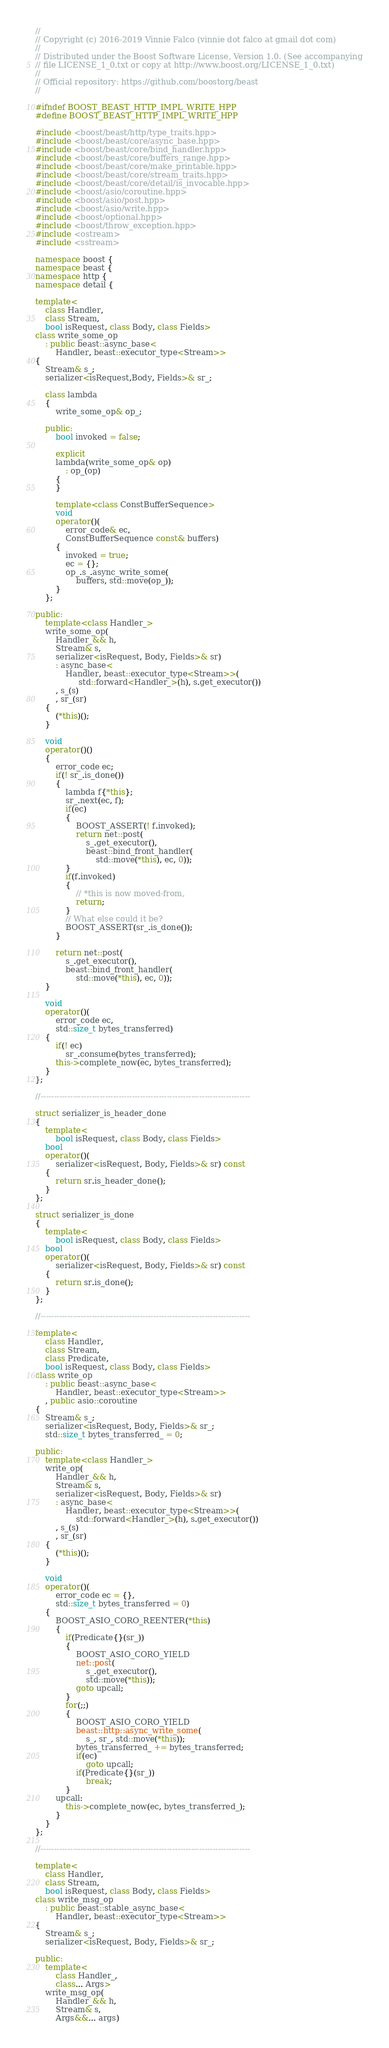Convert code to text. <code><loc_0><loc_0><loc_500><loc_500><_C++_>//
// Copyright (c) 2016-2019 Vinnie Falco (vinnie dot falco at gmail dot com)
//
// Distributed under the Boost Software License, Version 1.0. (See accompanying
// file LICENSE_1_0.txt or copy at http://www.boost.org/LICENSE_1_0.txt)
//
// Official repository: https://github.com/boostorg/beast
//

#ifndef BOOST_BEAST_HTTP_IMPL_WRITE_HPP
#define BOOST_BEAST_HTTP_IMPL_WRITE_HPP

#include <boost/beast/http/type_traits.hpp>
#include <boost/beast/core/async_base.hpp>
#include <boost/beast/core/bind_handler.hpp>
#include <boost/beast/core/buffers_range.hpp>
#include <boost/beast/core/make_printable.hpp>
#include <boost/beast/core/stream_traits.hpp>
#include <boost/beast/core/detail/is_invocable.hpp>
#include <boost/asio/coroutine.hpp>
#include <boost/asio/post.hpp>
#include <boost/asio/write.hpp>
#include <boost/optional.hpp>
#include <boost/throw_exception.hpp>
#include <ostream>
#include <sstream>

namespace boost {
namespace beast {
namespace http {
namespace detail {

template<
    class Handler,
    class Stream,
    bool isRequest, class Body, class Fields>
class write_some_op
    : public beast::async_base<
        Handler, beast::executor_type<Stream>>
{
    Stream& s_;
    serializer<isRequest,Body, Fields>& sr_;

    class lambda
    {
        write_some_op& op_;

    public:
        bool invoked = false;

        explicit
        lambda(write_some_op& op)
            : op_(op)
        {
        }

        template<class ConstBufferSequence>
        void
        operator()(
            error_code& ec,
            ConstBufferSequence const& buffers)
        {
            invoked = true;
            ec = {};
            op_.s_.async_write_some(
                buffers, std::move(op_));
        }
    };

public:
    template<class Handler_>
    write_some_op(
        Handler_&& h,
        Stream& s,
        serializer<isRequest, Body, Fields>& sr)
        : async_base<
            Handler, beast::executor_type<Stream>>(
                 std::forward<Handler_>(h), s.get_executor())
        , s_(s)
        , sr_(sr)
    {
        (*this)();
    }

    void
    operator()()
    {
        error_code ec;
        if(! sr_.is_done())
        {
            lambda f{*this};
            sr_.next(ec, f);
            if(ec)
            {
                BOOST_ASSERT(! f.invoked);
                return net::post(
                    s_.get_executor(),
                    beast::bind_front_handler(
                        std::move(*this), ec, 0));
            }
            if(f.invoked)
            {
                // *this is now moved-from,
                return;
            }
            // What else could it be?
            BOOST_ASSERT(sr_.is_done());
        }

        return net::post(
            s_.get_executor(),
            beast::bind_front_handler(
                std::move(*this), ec, 0));
    }

    void
    operator()(
        error_code ec,
        std::size_t bytes_transferred)
    {
        if(! ec)
            sr_.consume(bytes_transferred);
        this->complete_now(ec, bytes_transferred);
    }
};

//------------------------------------------------------------------------------

struct serializer_is_header_done
{
    template<
        bool isRequest, class Body, class Fields>
    bool
    operator()(
        serializer<isRequest, Body, Fields>& sr) const
    {
        return sr.is_header_done();
    }
};

struct serializer_is_done
{
    template<
        bool isRequest, class Body, class Fields>
    bool
    operator()(
        serializer<isRequest, Body, Fields>& sr) const
    {
        return sr.is_done();
    }
};

//------------------------------------------------------------------------------

template<
    class Handler,
    class Stream,
    class Predicate,
    bool isRequest, class Body, class Fields>
class write_op
    : public beast::async_base<
        Handler, beast::executor_type<Stream>>
    , public asio::coroutine
{
    Stream& s_;
    serializer<isRequest, Body, Fields>& sr_;
    std::size_t bytes_transferred_ = 0;

public:
    template<class Handler_>
    write_op(
        Handler_&& h,
        Stream& s,
        serializer<isRequest, Body, Fields>& sr)
        : async_base<
            Handler, beast::executor_type<Stream>>(
                std::forward<Handler_>(h), s.get_executor())
        , s_(s)
        , sr_(sr)
    {
        (*this)();
    }

    void
    operator()(
        error_code ec = {},
        std::size_t bytes_transferred = 0)
    {
        BOOST_ASIO_CORO_REENTER(*this)
        {
            if(Predicate{}(sr_))
            {
                BOOST_ASIO_CORO_YIELD
                net::post(
                    s_.get_executor(),
                    std::move(*this));
                goto upcall;
            }
            for(;;)
            {
                BOOST_ASIO_CORO_YIELD
                beast::http::async_write_some(
                    s_, sr_, std::move(*this));
                bytes_transferred_ += bytes_transferred;
                if(ec)
                    goto upcall;
                if(Predicate{}(sr_))
                    break;
            }
        upcall:
            this->complete_now(ec, bytes_transferred_);
        }
    }
};

//------------------------------------------------------------------------------

template<
    class Handler,
    class Stream,
    bool isRequest, class Body, class Fields>
class write_msg_op
    : public beast::stable_async_base<
        Handler, beast::executor_type<Stream>>
{
    Stream& s_;
    serializer<isRequest, Body, Fields>& sr_;

public:
    template<
        class Handler_,
        class... Args>
    write_msg_op(
        Handler_&& h,
        Stream& s,
        Args&&... args)</code> 